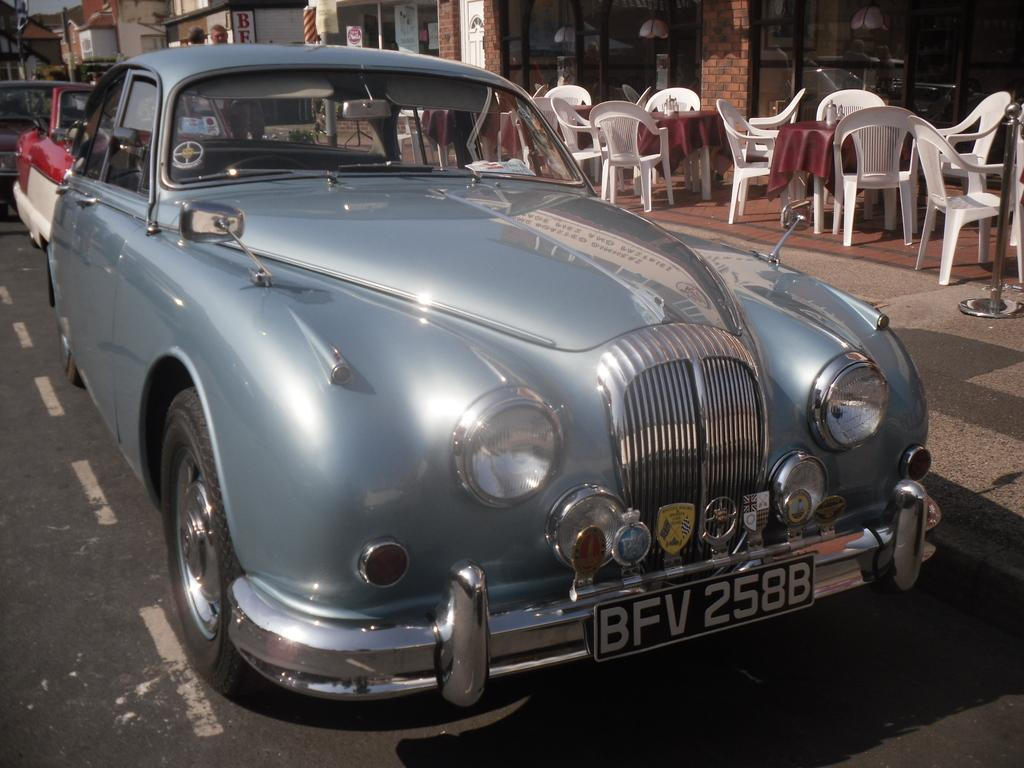What type of vehicle is present in the image? There is a car in the image. What type of furniture can be seen in the image? There are chairs and a table in the image. What is visible in the background of the image? There is a building in the background of the image. Can you describe the person in the image? There is a person standing in the image. What type of zipper can be seen on the person's clothing in the image? There is no zipper visible on the person's clothing in the image. What type of support is provided by the chairs in the image? The chairs in the image are not shown providing any support, as they are not being used. 